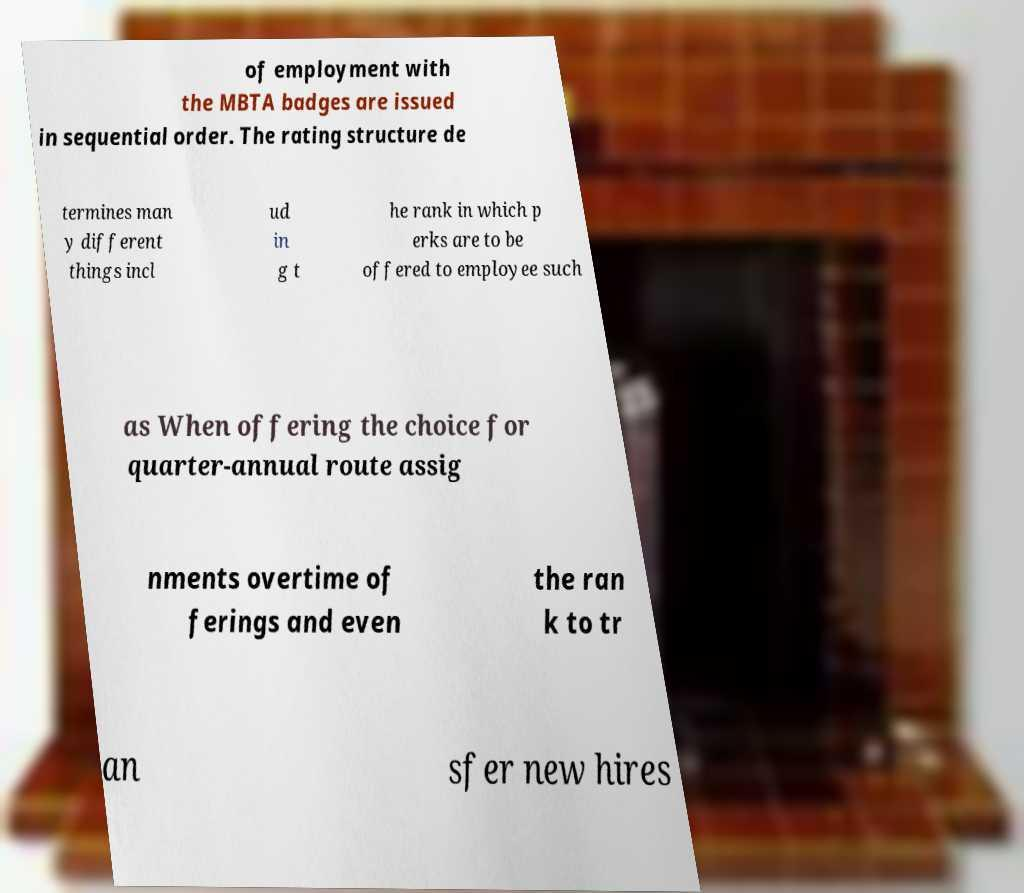Can you read and provide the text displayed in the image?This photo seems to have some interesting text. Can you extract and type it out for me? of employment with the MBTA badges are issued in sequential order. The rating structure de termines man y different things incl ud in g t he rank in which p erks are to be offered to employee such as When offering the choice for quarter-annual route assig nments overtime of ferings and even the ran k to tr an sfer new hires 